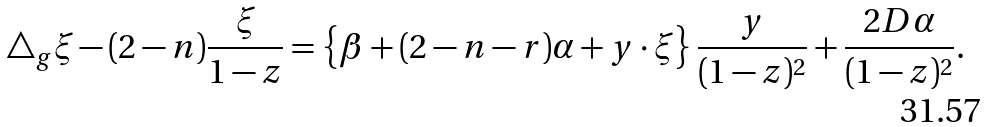<formula> <loc_0><loc_0><loc_500><loc_500>\triangle _ { g } \xi - ( 2 - n ) \frac { \xi } { 1 - z } = \left \{ \beta + ( 2 - n - r ) \alpha + y \cdot \xi \right \} \frac { y } { ( 1 - z ) ^ { 2 } } + \frac { 2 D \alpha } { ( 1 - z ) ^ { 2 } } .</formula> 